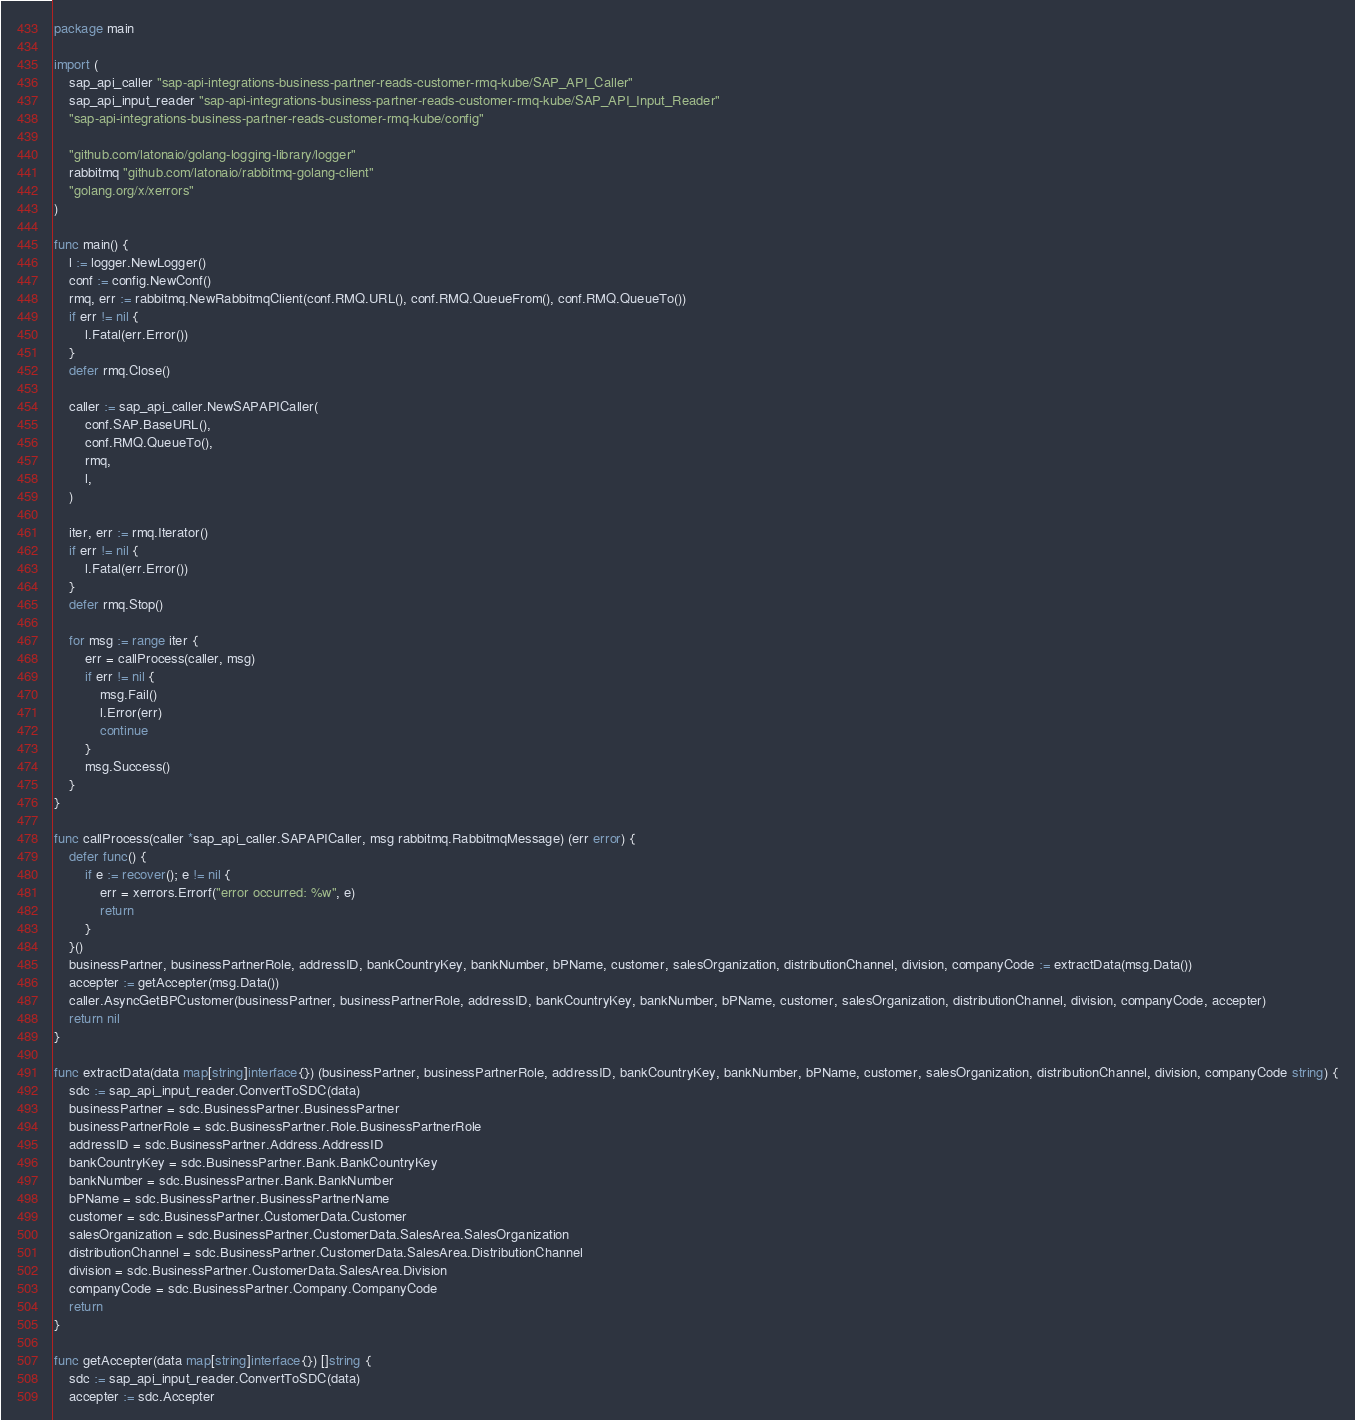<code> <loc_0><loc_0><loc_500><loc_500><_Go_>package main

import (
	sap_api_caller "sap-api-integrations-business-partner-reads-customer-rmq-kube/SAP_API_Caller"
	sap_api_input_reader "sap-api-integrations-business-partner-reads-customer-rmq-kube/SAP_API_Input_Reader"
	"sap-api-integrations-business-partner-reads-customer-rmq-kube/config"

	"github.com/latonaio/golang-logging-library/logger"
	rabbitmq "github.com/latonaio/rabbitmq-golang-client"
	"golang.org/x/xerrors"
)

func main() {
	l := logger.NewLogger()
	conf := config.NewConf()
	rmq, err := rabbitmq.NewRabbitmqClient(conf.RMQ.URL(), conf.RMQ.QueueFrom(), conf.RMQ.QueueTo())
	if err != nil {
		l.Fatal(err.Error())
	}
	defer rmq.Close()

	caller := sap_api_caller.NewSAPAPICaller(
		conf.SAP.BaseURL(),
		conf.RMQ.QueueTo(),
		rmq,
		l,
	)

	iter, err := rmq.Iterator()
	if err != nil {
		l.Fatal(err.Error())
	}
	defer rmq.Stop()

	for msg := range iter {
		err = callProcess(caller, msg)
		if err != nil {
			msg.Fail()
			l.Error(err)
			continue
		}
		msg.Success()
	}
}

func callProcess(caller *sap_api_caller.SAPAPICaller, msg rabbitmq.RabbitmqMessage) (err error) {
	defer func() {
		if e := recover(); e != nil {
			err = xerrors.Errorf("error occurred: %w", e)
			return
		}
	}()
	businessPartner, businessPartnerRole, addressID, bankCountryKey, bankNumber, bPName, customer, salesOrganization, distributionChannel, division, companyCode := extractData(msg.Data())
	accepter := getAccepter(msg.Data())
	caller.AsyncGetBPCustomer(businessPartner, businessPartnerRole, addressID, bankCountryKey, bankNumber, bPName, customer, salesOrganization, distributionChannel, division, companyCode, accepter)
	return nil
}

func extractData(data map[string]interface{}) (businessPartner, businessPartnerRole, addressID, bankCountryKey, bankNumber, bPName, customer, salesOrganization, distributionChannel, division, companyCode string) {
	sdc := sap_api_input_reader.ConvertToSDC(data)
	businessPartner = sdc.BusinessPartner.BusinessPartner
	businessPartnerRole = sdc.BusinessPartner.Role.BusinessPartnerRole
	addressID = sdc.BusinessPartner.Address.AddressID
	bankCountryKey = sdc.BusinessPartner.Bank.BankCountryKey
	bankNumber = sdc.BusinessPartner.Bank.BankNumber
	bPName = sdc.BusinessPartner.BusinessPartnerName
	customer = sdc.BusinessPartner.CustomerData.Customer
	salesOrganization = sdc.BusinessPartner.CustomerData.SalesArea.SalesOrganization
	distributionChannel = sdc.BusinessPartner.CustomerData.SalesArea.DistributionChannel
	division = sdc.BusinessPartner.CustomerData.SalesArea.Division
	companyCode = sdc.BusinessPartner.Company.CompanyCode
	return
}

func getAccepter(data map[string]interface{}) []string {
	sdc := sap_api_input_reader.ConvertToSDC(data)
	accepter := sdc.Accepter</code> 